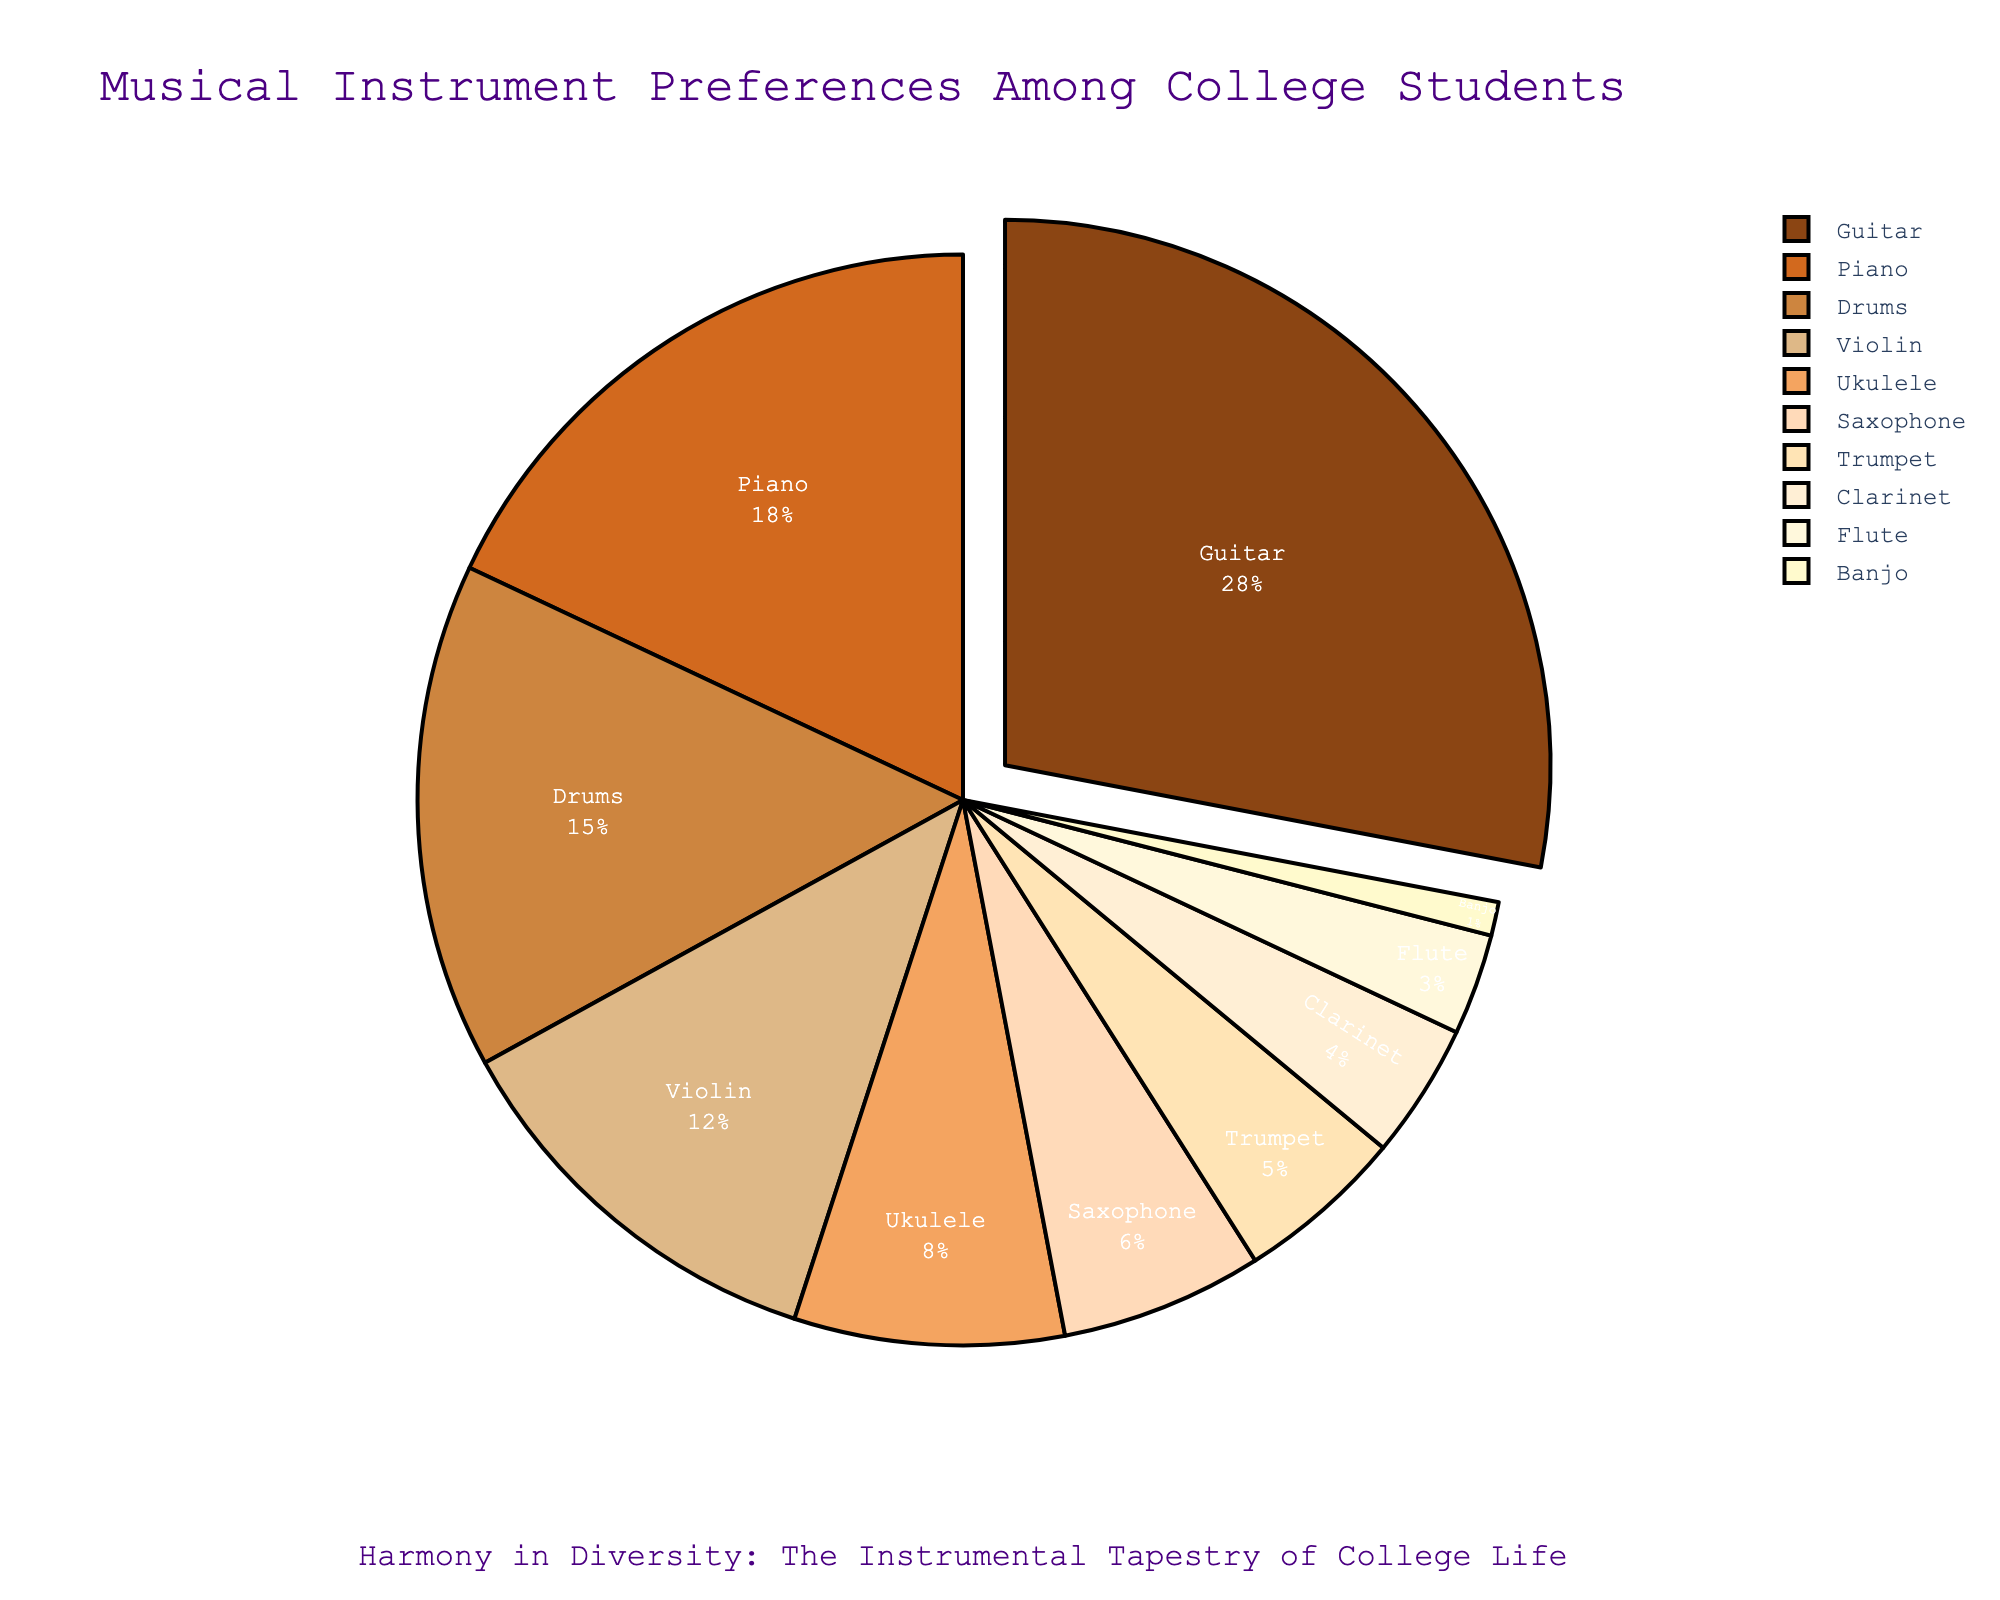Which instrument do the highest percentage of college students prefer? The pie chart shows that Guitar has the largest section, indicating the highest preference among college students.
Answer: Guitar Which two instruments have the smallest percentage of preference combined? The smallest sections in the pie chart are for Banjo and Flute. Adding their percentages, 1% + 3% = 4%.
Answer: Banjo and Flute How much greater is the preference for Guitar compared to Ukulele? The percentage for Guitar is 28%, and for Ukulele, it is 8%. The difference is 28% - 8% = 20%.
Answer: 20% What is the combined percentage preference for Piano and Drums? The chart shows Piano at 18% and Drums at 15%. Adding these together, 18% + 15% = 33%.
Answer: 33% Which three instruments, when combined, make up the majority (>50%) of preferences? The top three instruments by percentage are Guitar (28%), Piano (18%), and Drums (15%). Adding them together gives 28% + 18% + 15% = 61%, which is more than 50%.
Answer: Guitar, Piano, and Drums How much less is the preference for Clarinet compared to Trumpet? The percentage for Clarinet is 4%, and for Trumpet, it is 5%. The difference is 5% - 4% = 1%.
Answer: 1% Compare the preferences for Violin and Saxophone. Which is higher, and by how much? Violin has a percentage of 12%, and Saxophone has 6%. Violin is higher by 12% - 6% = 6%.
Answer: Violin by 6% What percentage of preferences do the top four instruments combine for? The top four instruments are Guitar (28%), Piano (18%), Drums (15%), and Violin (12%). Summing these, 28% + 18% + 15% + 12% = 73%.
Answer: 73% What visual feature distinguishes the most preferred instrument on the pie chart? The most preferred instrument, Guitar, has a section that is visually "pulled out" slightly from the rest of the chart to highlight it.
Answer: Pulled out section Identify two instruments with a combined preference percentage closest to 20%. Saxophone (6%) and Ukulele (8%) combined give 6% + 8% = 14%, and adding Flute (3%), the closest combination is 6% + 8% + 3% = 17%.
Answer: Saxophone, Ukulele, and Flute 